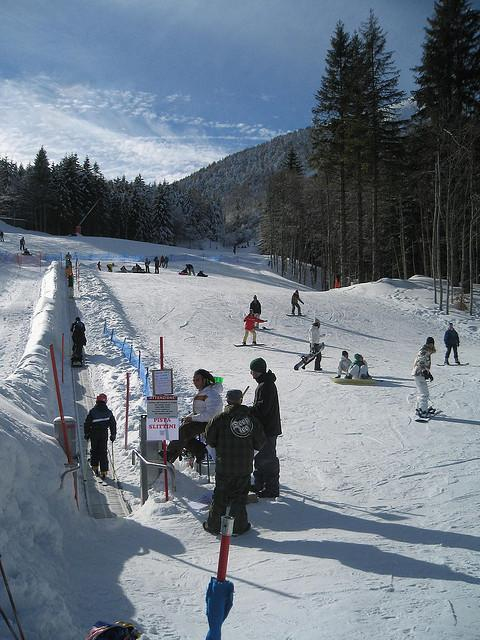What level of skier is this part of the hill designed for?

Choices:
A) advanced
B) expert
C) intermediate
D) beginner beginner 